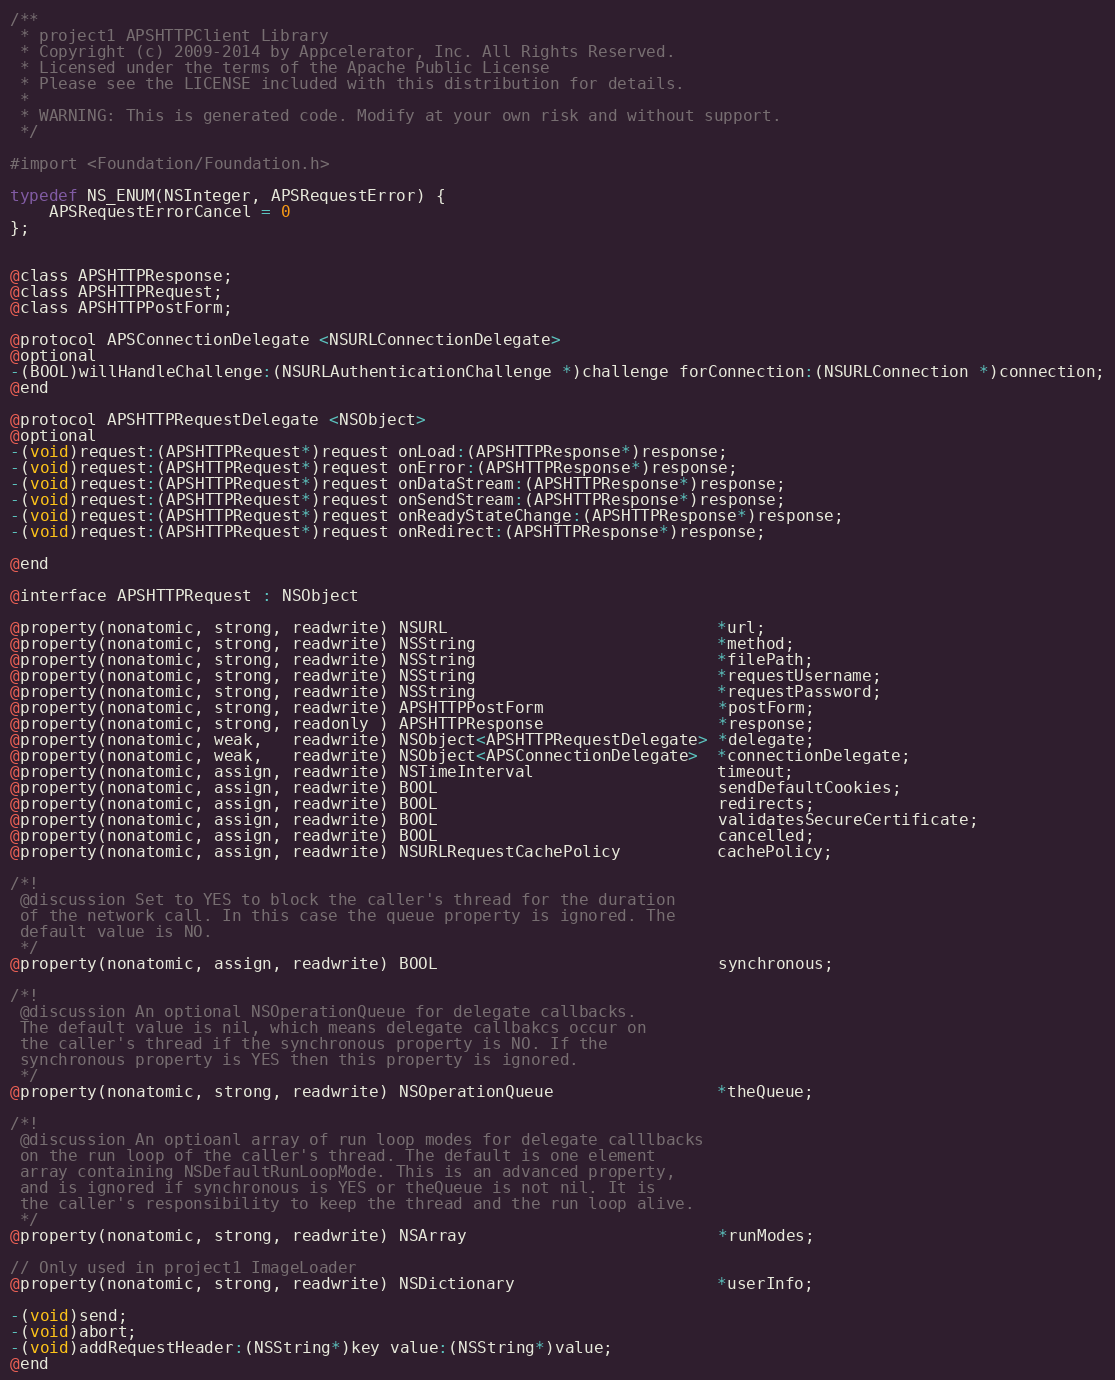<code> <loc_0><loc_0><loc_500><loc_500><_C_>/**
 * project1 APSHTTPClient Library
 * Copyright (c) 2009-2014 by Appcelerator, Inc. All Rights Reserved.
 * Licensed under the terms of the Apache Public License
 * Please see the LICENSE included with this distribution for details.
 * 
 * WARNING: This is generated code. Modify at your own risk and without support.
 */

#import <Foundation/Foundation.h>

typedef NS_ENUM(NSInteger, APSRequestError) {
	APSRequestErrorCancel = 0
};


@class APSHTTPResponse;
@class APSHTTPRequest;
@class APSHTTPPostForm;

@protocol APSConnectionDelegate <NSURLConnectionDelegate>
@optional
-(BOOL)willHandleChallenge:(NSURLAuthenticationChallenge *)challenge forConnection:(NSURLConnection *)connection;
@end

@protocol APSHTTPRequestDelegate <NSObject>
@optional
-(void)request:(APSHTTPRequest*)request onLoad:(APSHTTPResponse*)response;
-(void)request:(APSHTTPRequest*)request onError:(APSHTTPResponse*)response;
-(void)request:(APSHTTPRequest*)request onDataStream:(APSHTTPResponse*)response;
-(void)request:(APSHTTPRequest*)request onSendStream:(APSHTTPResponse*)response;
-(void)request:(APSHTTPRequest*)request onReadyStateChange:(APSHTTPResponse*)response;
-(void)request:(APSHTTPRequest*)request onRedirect:(APSHTTPResponse*)response;

@end

@interface APSHTTPRequest : NSObject

@property(nonatomic, strong, readwrite) NSURL                            *url;
@property(nonatomic, strong, readwrite) NSString                         *method;
@property(nonatomic, strong, readwrite) NSString                         *filePath;
@property(nonatomic, strong, readwrite) NSString                         *requestUsername;
@property(nonatomic, strong, readwrite) NSString                         *requestPassword;
@property(nonatomic, strong, readwrite) APSHTTPPostForm                  *postForm;
@property(nonatomic, strong, readonly ) APSHTTPResponse                  *response;
@property(nonatomic, weak,   readwrite) NSObject<APSHTTPRequestDelegate> *delegate;
@property(nonatomic, weak,   readwrite) NSObject<APSConnectionDelegate>  *connectionDelegate;
@property(nonatomic, assign, readwrite) NSTimeInterval                   timeout;
@property(nonatomic, assign, readwrite) BOOL                             sendDefaultCookies;
@property(nonatomic, assign, readwrite) BOOL                             redirects;
@property(nonatomic, assign, readwrite) BOOL                             validatesSecureCertificate;
@property(nonatomic, assign, readwrite) BOOL                             cancelled;
@property(nonatomic, assign, readwrite) NSURLRequestCachePolicy          cachePolicy;

/*!
 @discussion Set to YES to block the caller's thread for the duration
 of the network call. In this case the queue property is ignored. The
 default value is NO.
 */
@property(nonatomic, assign, readwrite) BOOL                             synchronous;

/*!
 @discussion An optional NSOperationQueue for delegate callbacks.
 The default value is nil, which means delegate callbakcs occur on
 the caller's thread if the synchronous property is NO. If the 
 synchronous property is YES then this property is ignored.
 */
@property(nonatomic, strong, readwrite) NSOperationQueue                 *theQueue;

/*!
 @discussion An optioanl array of run loop modes for delegate calllbacks
 on the run loop of the caller's thread. The default is one element 
 array containing NSDefaultRunLoopMode. This is an advanced property,
 and is ignored if synchronous is YES or theQueue is not nil. It is
 the caller's responsibility to keep the thread and the run loop alive.
 */
@property(nonatomic, strong, readwrite) NSArray                          *runModes;

// Only used in project1 ImageLoader
@property(nonatomic, strong, readwrite) NSDictionary                     *userInfo;

-(void)send;
-(void)abort;
-(void)addRequestHeader:(NSString*)key value:(NSString*)value;
@end
</code> 